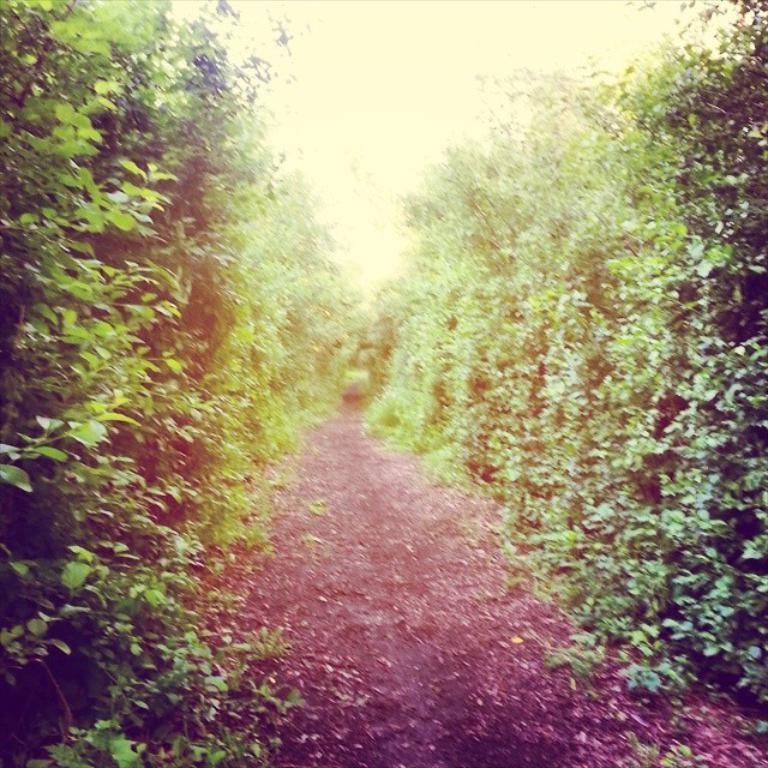How would you summarize this image in a sentence or two? In this picture there are trees on the right and left side of the image and there is path in the center of the image. 